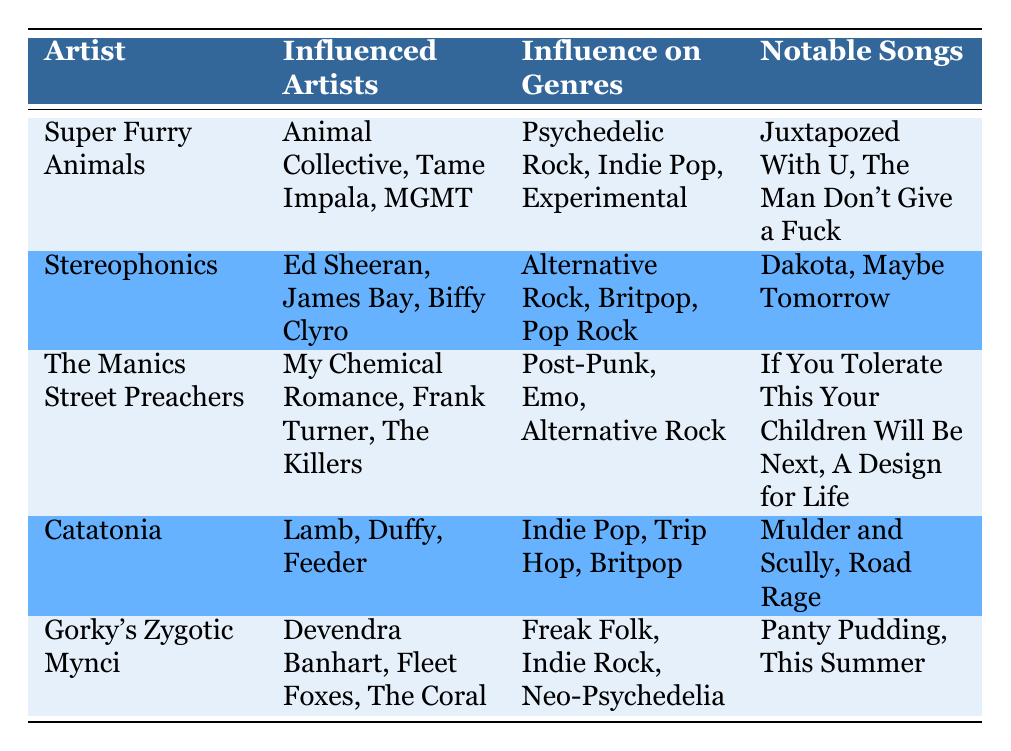What artists influenced Super Furry Animals? From the table, Super Furry Animals influenced Animal Collective, Tame Impala, and MGMT. These names are listed in the "Influenced Artists" column for Super Furry Animals.
Answer: Animal Collective, Tame Impala, MGMT Name a notable song by the Manics Street Preachers. The table lists two notable songs for the Manics Street Preachers: "If You Tolerate This Your Children Will Be Next" and "A Design for Life." You can refer to this directly from the "Notable Songs" column.
Answer: If You Tolerate This Your Children Will Be Next Which genres were influenced by Catatonia? Catatonia influenced the genres: Indie Pop, Trip Hop, and Britpop. This information can be found in the "Influence on Genres" column corresponding to Catatonia.
Answer: Indie Pop, Trip Hop, Britpop Do Stereophonics have songs listed as notable in the table? Yes, the Stereophonics have notable songs listed in the table: "Dakota" and "Maybe Tomorrow." This can be confirmed by looking at the "Notable Songs" column for Stereophonics.
Answer: Yes Which artist influenced the most influenced artists listed in the table? To determine which artist has influenced the most artists, count the number of names in the "Influenced Artists" columns. Super Furry Animals, Stereophonics, The Manics Street Preachers, Catatonia, and Gorky's Zygotic Mynci each have three names listed, so they are tied.
Answer: Tied (3 artists each) Is Gorky's Zygotic Mynci categorized under Psychedelic Rock? No, Gorky's Zygotic Mynci is categorized under Freak Folk, Indie Rock, and Neo-Psychedelia, according to the "Influence on Genres" column. There is no mention of Psychedelic Rock.
Answer: No What is the common influence genre shared by both the Manics Street Preachers and Stereophonics? To find the common genre, look at the "Influence on Genres" entries of both artists. The Stereophonics include Alternative Rock, while the Manics Street Preachers include it too, so it’s the common genre.
Answer: Alternative Rock Which influenced artists from Gorky's Zygotic Mynci are related to the Neo-Psychedelia genre? The influenced artists from Gorky's Zygotic Mynci are Devendra Banhart, Fleet Foxes, and The Coral. They relate to the Neo-Psychedelia genre mentioned for Gorky's Zygotic Mynci in the "Influence on Genres."
Answer: Devendra Banhart, Fleet Foxes, The Coral How many different genres are mentioned in total for Super Furry Animals? Super Furry Animals have three genres listed: Psychedelic Rock, Indie Pop, and Experimental. Count these to find the total.
Answer: 3 